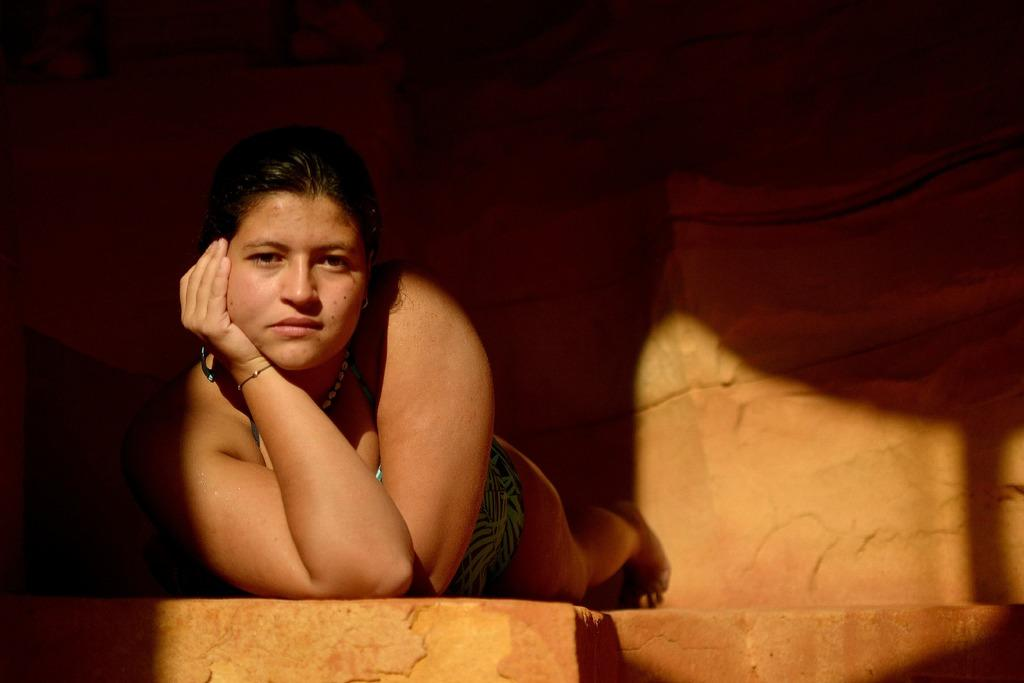Who is the main subject in the image? There is a woman in the image. What is the woman doing in the image? The woman is lying on a brown rock and giving a pose. What is the color of the rock the woman is lying on? The rock the woman is lying on is brown. What can be seen in the background of the image? There is a brown rock wall in the background of the image. What type of leg is the woman using to climb the rock wall in the image? There is no indication in the image that the woman is climbing a rock wall, nor is there any mention of a leg being used for that purpose. 